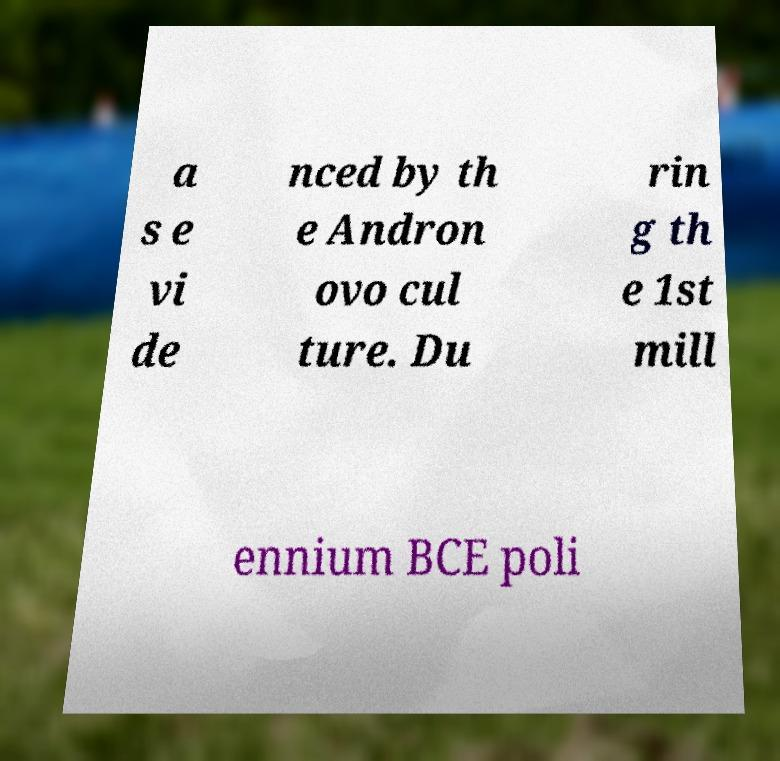I need the written content from this picture converted into text. Can you do that? a s e vi de nced by th e Andron ovo cul ture. Du rin g th e 1st mill ennium BCE poli 